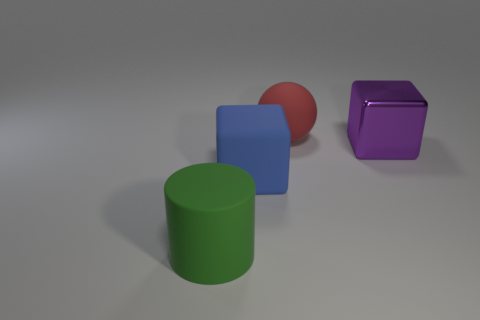Is there any other thing that has the same material as the big purple thing?
Your response must be concise. No. There is a large rubber object that is behind the purple metal thing; what number of blue matte cubes are behind it?
Ensure brevity in your answer.  0. Is the number of big red rubber balls that are to the right of the purple thing less than the number of blue rubber objects?
Give a very brief answer. Yes. There is a big block left of the big thing that is right of the red thing; are there any big matte objects that are to the left of it?
Your answer should be very brief. Yes. Does the big red sphere have the same material as the thing on the right side of the large red rubber thing?
Your answer should be very brief. No. There is a big cube right of the big rubber object behind the blue matte block; what is its color?
Ensure brevity in your answer.  Purple. There is a rubber object that is in front of the big block that is to the left of the big cube on the right side of the blue rubber cube; what is its size?
Your response must be concise. Large. There is a green object; is its shape the same as the object that is on the right side of the red sphere?
Provide a short and direct response. No. What number of other things are the same size as the purple shiny object?
Give a very brief answer. 3. What is the size of the cube right of the big red rubber ball?
Offer a terse response. Large. 